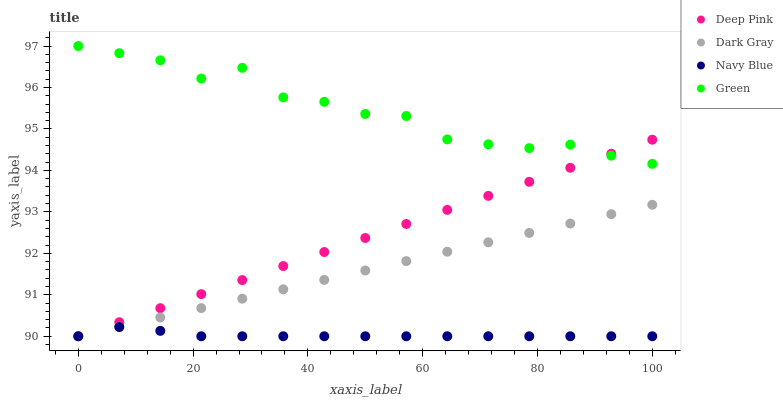Does Navy Blue have the minimum area under the curve?
Answer yes or no. Yes. Does Green have the maximum area under the curve?
Answer yes or no. Yes. Does Deep Pink have the minimum area under the curve?
Answer yes or no. No. Does Deep Pink have the maximum area under the curve?
Answer yes or no. No. Is Deep Pink the smoothest?
Answer yes or no. Yes. Is Green the roughest?
Answer yes or no. Yes. Is Navy Blue the smoothest?
Answer yes or no. No. Is Navy Blue the roughest?
Answer yes or no. No. Does Dark Gray have the lowest value?
Answer yes or no. Yes. Does Green have the lowest value?
Answer yes or no. No. Does Green have the highest value?
Answer yes or no. Yes. Does Deep Pink have the highest value?
Answer yes or no. No. Is Dark Gray less than Green?
Answer yes or no. Yes. Is Green greater than Navy Blue?
Answer yes or no. Yes. Does Dark Gray intersect Navy Blue?
Answer yes or no. Yes. Is Dark Gray less than Navy Blue?
Answer yes or no. No. Is Dark Gray greater than Navy Blue?
Answer yes or no. No. Does Dark Gray intersect Green?
Answer yes or no. No. 